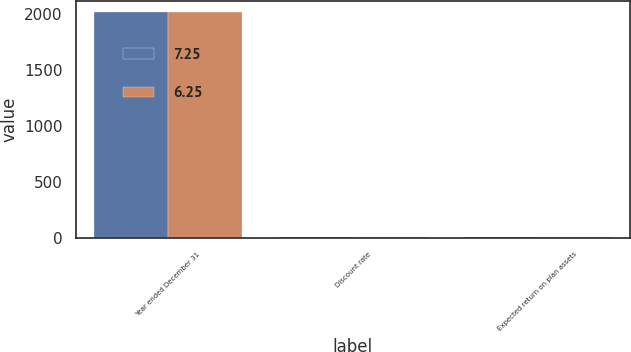Convert chart. <chart><loc_0><loc_0><loc_500><loc_500><stacked_bar_chart><ecel><fcel>Year ended December 31<fcel>Discount rate<fcel>Expected return on plan assets<nl><fcel>7.25<fcel>2015<fcel>3.5<fcel>6.25<nl><fcel>6.25<fcel>2014<fcel>4.25<fcel>7.25<nl></chart> 